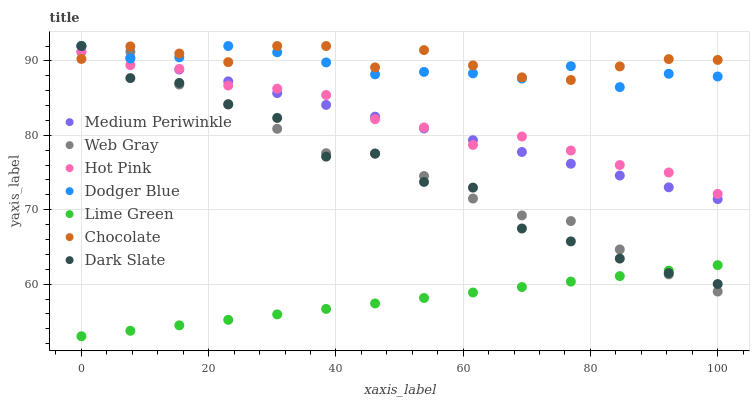Does Lime Green have the minimum area under the curve?
Answer yes or no. Yes. Does Chocolate have the maximum area under the curve?
Answer yes or no. Yes. Does Hot Pink have the minimum area under the curve?
Answer yes or no. No. Does Hot Pink have the maximum area under the curve?
Answer yes or no. No. Is Lime Green the smoothest?
Answer yes or no. Yes. Is Dark Slate the roughest?
Answer yes or no. Yes. Is Hot Pink the smoothest?
Answer yes or no. No. Is Hot Pink the roughest?
Answer yes or no. No. Does Lime Green have the lowest value?
Answer yes or no. Yes. Does Hot Pink have the lowest value?
Answer yes or no. No. Does Dodger Blue have the highest value?
Answer yes or no. Yes. Does Hot Pink have the highest value?
Answer yes or no. No. Is Lime Green less than Chocolate?
Answer yes or no. Yes. Is Hot Pink greater than Lime Green?
Answer yes or no. Yes. Does Web Gray intersect Dodger Blue?
Answer yes or no. Yes. Is Web Gray less than Dodger Blue?
Answer yes or no. No. Is Web Gray greater than Dodger Blue?
Answer yes or no. No. Does Lime Green intersect Chocolate?
Answer yes or no. No. 